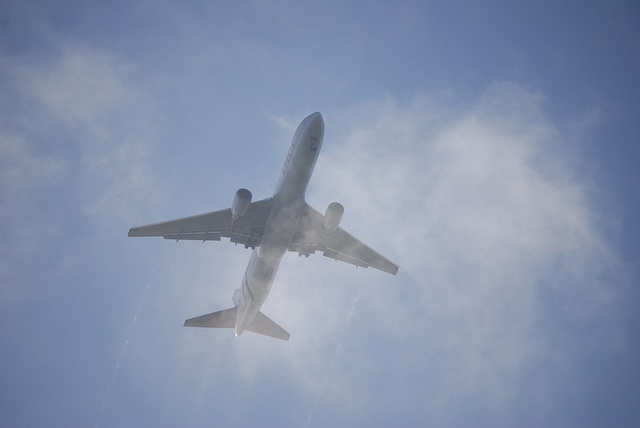Describe the objects in this image and their specific colors. I can see a airplane in gray tones in this image. 